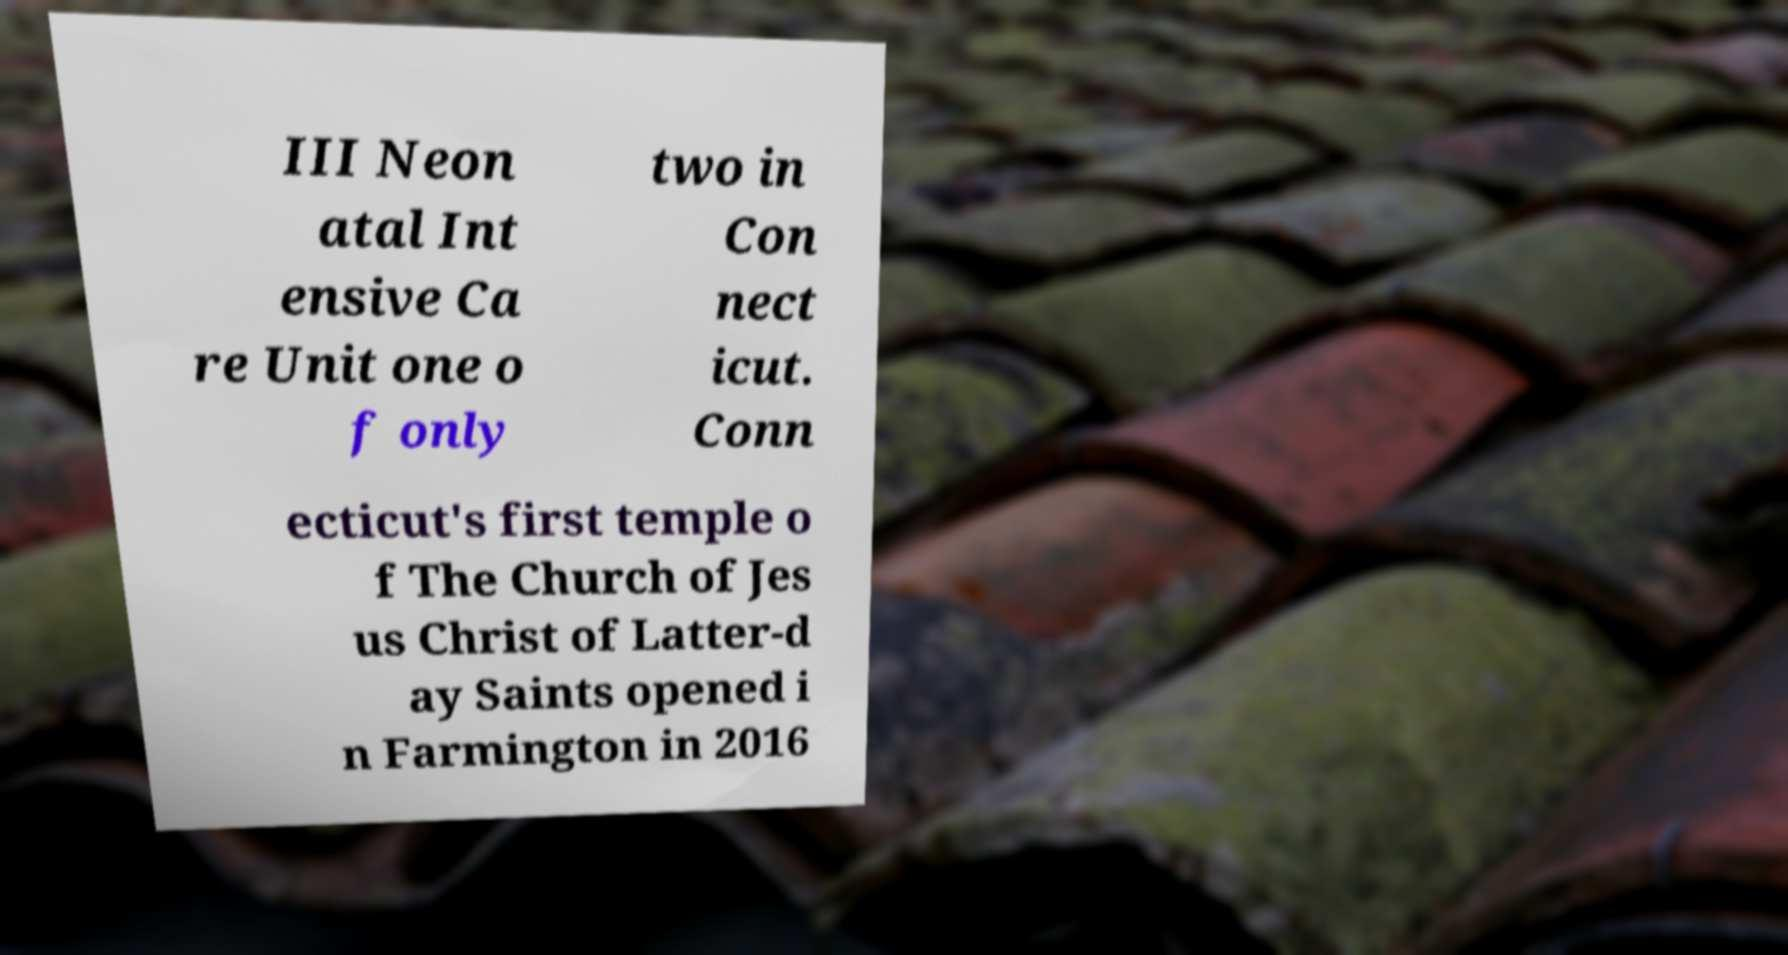Could you assist in decoding the text presented in this image and type it out clearly? III Neon atal Int ensive Ca re Unit one o f only two in Con nect icut. Conn ecticut's first temple o f The Church of Jes us Christ of Latter-d ay Saints opened i n Farmington in 2016 